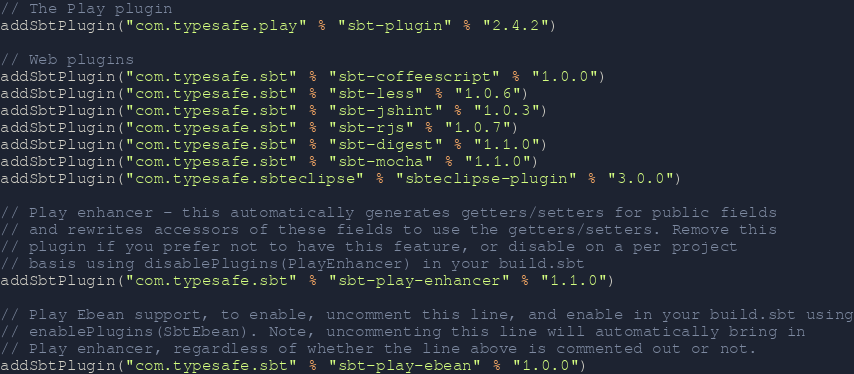<code> <loc_0><loc_0><loc_500><loc_500><_Scala_>// The Play plugin
addSbtPlugin("com.typesafe.play" % "sbt-plugin" % "2.4.2")

// Web plugins
addSbtPlugin("com.typesafe.sbt" % "sbt-coffeescript" % "1.0.0")
addSbtPlugin("com.typesafe.sbt" % "sbt-less" % "1.0.6")
addSbtPlugin("com.typesafe.sbt" % "sbt-jshint" % "1.0.3")
addSbtPlugin("com.typesafe.sbt" % "sbt-rjs" % "1.0.7")
addSbtPlugin("com.typesafe.sbt" % "sbt-digest" % "1.1.0")
addSbtPlugin("com.typesafe.sbt" % "sbt-mocha" % "1.1.0")
addSbtPlugin("com.typesafe.sbteclipse" % "sbteclipse-plugin" % "3.0.0")

// Play enhancer - this automatically generates getters/setters for public fields
// and rewrites accessors of these fields to use the getters/setters. Remove this
// plugin if you prefer not to have this feature, or disable on a per project
// basis using disablePlugins(PlayEnhancer) in your build.sbt
addSbtPlugin("com.typesafe.sbt" % "sbt-play-enhancer" % "1.1.0")

// Play Ebean support, to enable, uncomment this line, and enable in your build.sbt using
// enablePlugins(SbtEbean). Note, uncommenting this line will automatically bring in
// Play enhancer, regardless of whether the line above is commented out or not.
addSbtPlugin("com.typesafe.sbt" % "sbt-play-ebean" % "1.0.0")
</code> 